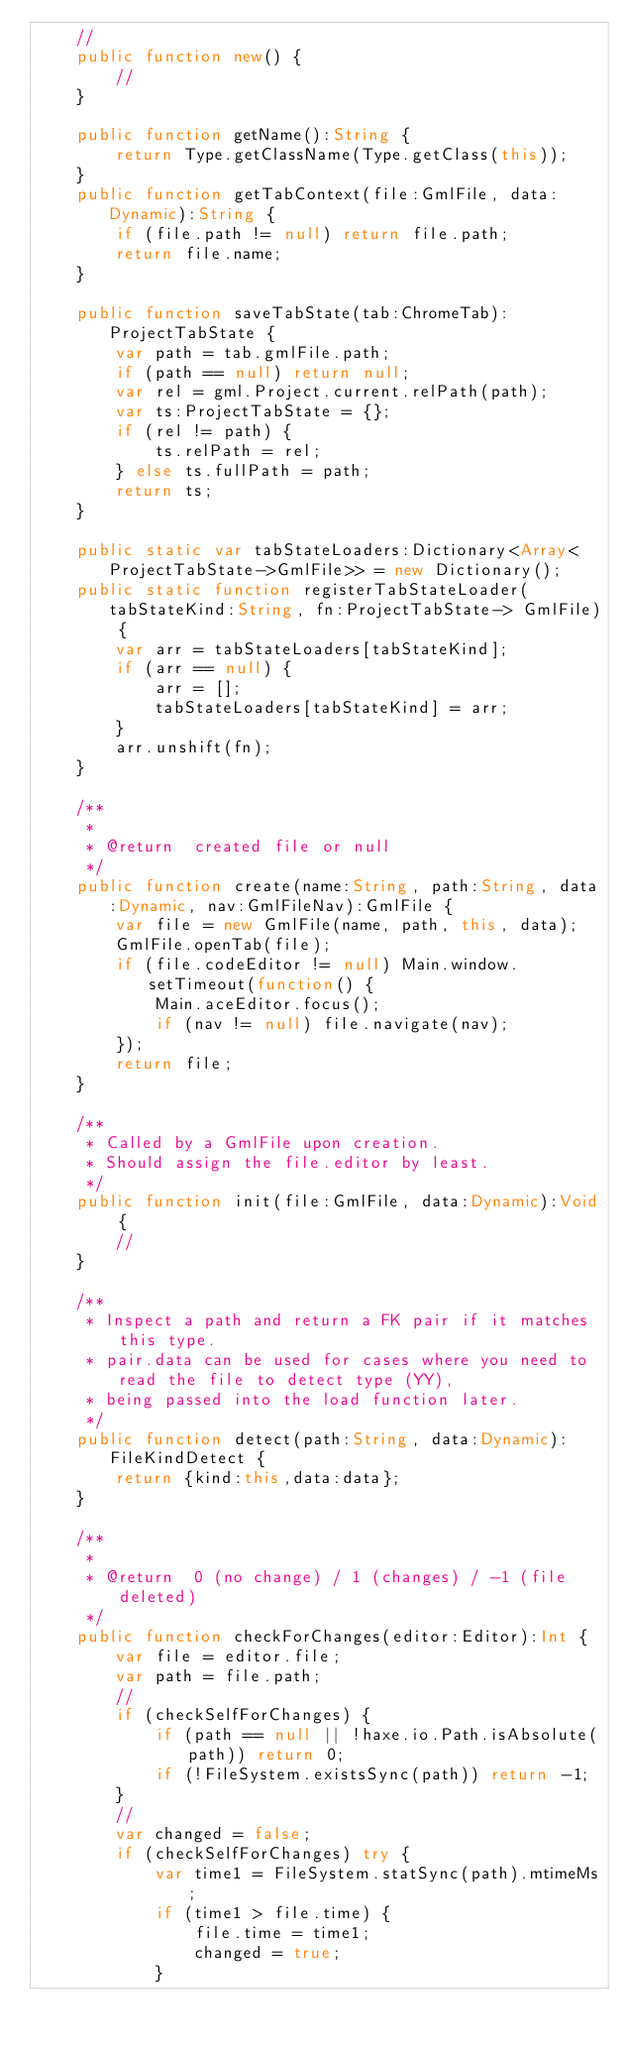<code> <loc_0><loc_0><loc_500><loc_500><_Haxe_>	//
	public function new() {
		//
	}
	
	public function getName():String {
		return Type.getClassName(Type.getClass(this));
	}
	public function getTabContext(file:GmlFile, data:Dynamic):String {
		if (file.path != null) return file.path;
		return file.name;
	}
	
	public function saveTabState(tab:ChromeTab):ProjectTabState {
		var path = tab.gmlFile.path;
		if (path == null) return null;
		var rel = gml.Project.current.relPath(path);
		var ts:ProjectTabState = {};
		if (rel != path) {
			ts.relPath = rel;
		} else ts.fullPath = path;
		return ts;
	}
	
	public static var tabStateLoaders:Dictionary<Array<ProjectTabState->GmlFile>> = new Dictionary();
	public static function registerTabStateLoader(tabStateKind:String, fn:ProjectTabState-> GmlFile) {
		var arr = tabStateLoaders[tabStateKind];
		if (arr == null) {
			arr = [];
			tabStateLoaders[tabStateKind] = arr;
		}
		arr.unshift(fn);
	}
	
	/**
	 * 
	 * @return	created file or null
	 */
	public function create(name:String, path:String, data:Dynamic, nav:GmlFileNav):GmlFile {
		var file = new GmlFile(name, path, this, data);
		GmlFile.openTab(file);
		if (file.codeEditor != null) Main.window.setTimeout(function() {
			Main.aceEditor.focus();
			if (nav != null) file.navigate(nav);
		});
		return file;
	}
	
	/**
	 * Called by a GmlFile upon creation.
	 * Should assign the file.editor by least.
	 */
	public function init(file:GmlFile, data:Dynamic):Void {
		//
	}
	
	/**
	 * Inspect a path and return a FK pair if it matches this type.
	 * pair.data can be used for cases where you need to read the file to detect type (YY),
	 * being passed into the load function later.
	 */
	public function detect(path:String, data:Dynamic):FileKindDetect {
		return {kind:this,data:data};
	}
	
	/**
	 * 
	 * @return	0 (no change) / 1 (changes) / -1 (file deleted)
	 */
	public function checkForChanges(editor:Editor):Int {
		var file = editor.file;
		var path = file.path;
		//
		if (checkSelfForChanges) {
			if (path == null || !haxe.io.Path.isAbsolute(path)) return 0;
			if (!FileSystem.existsSync(path)) return -1;
		}
		//
		var changed = false;
		if (checkSelfForChanges) try {
			var time1 = FileSystem.statSync(path).mtimeMs;
			if (time1 > file.time) {
				file.time = time1;
				changed = true;
			}</code> 